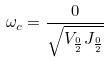Convert formula to latex. <formula><loc_0><loc_0><loc_500><loc_500>\omega _ { c } = \frac { 0 } { \sqrt { V _ { \frac { 0 } { 2 } } J _ { \frac { 0 } { 2 } } } }</formula> 